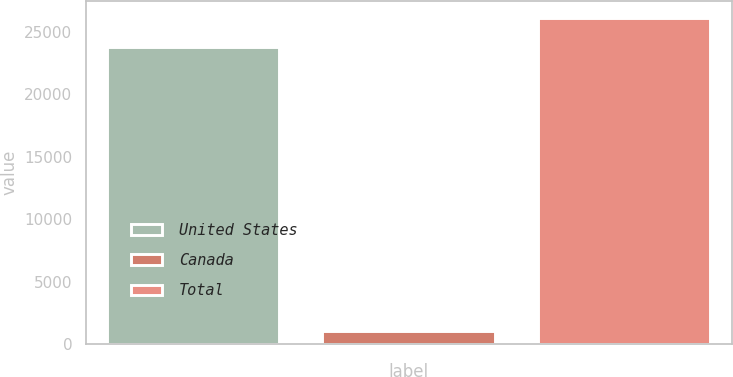Convert chart to OTSL. <chart><loc_0><loc_0><loc_500><loc_500><bar_chart><fcel>United States<fcel>Canada<fcel>Total<nl><fcel>23770<fcel>1031<fcel>26147<nl></chart> 